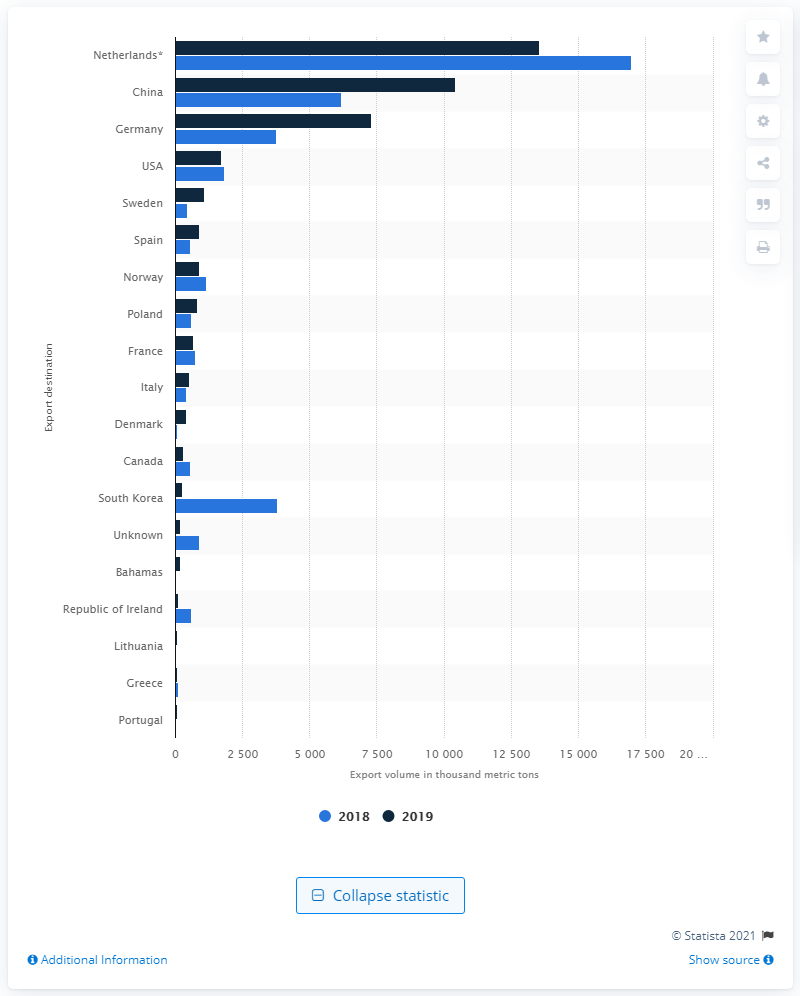List a handful of essential elements in this visual. Norway is the leading crude oil supplier to the United Kingdom. 